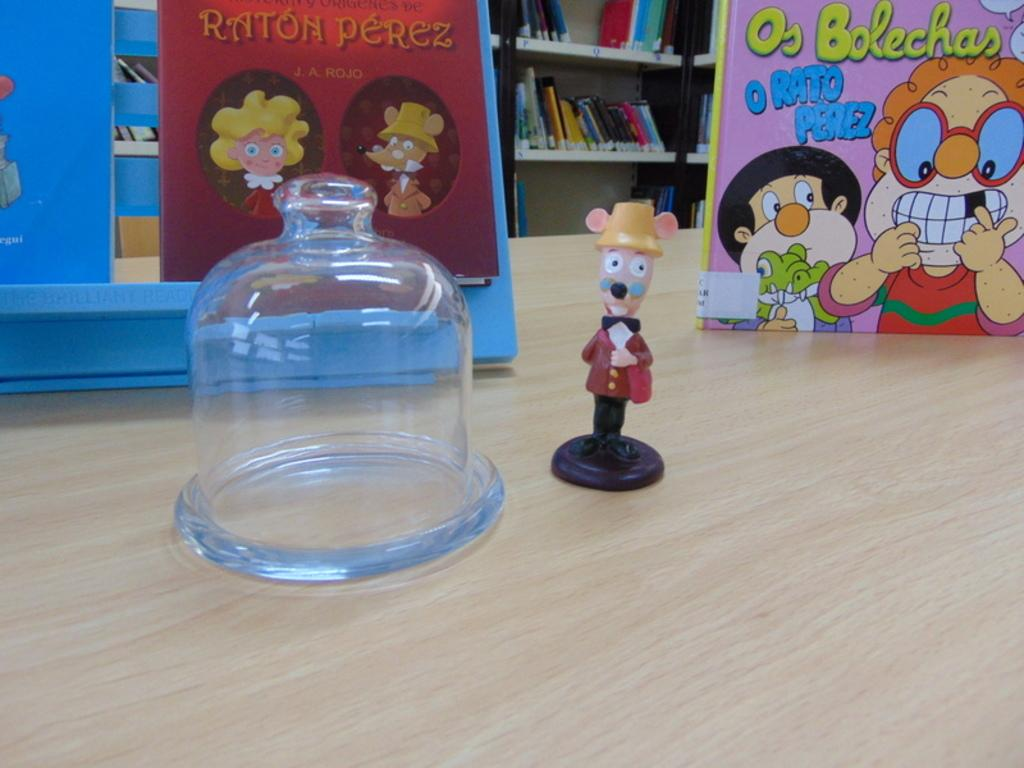What object can be seen in the image that is meant for play or entertainment? There is a toy in the image. What is on the table in the image? There is a board on a table in the image. What type of items can be seen in the background of the image? There are books visible in the background of the image, on a rack. What type of air is being used to write letters on the board in the image? There is no air or writing on the board in the image; it only shows a board on a table. 